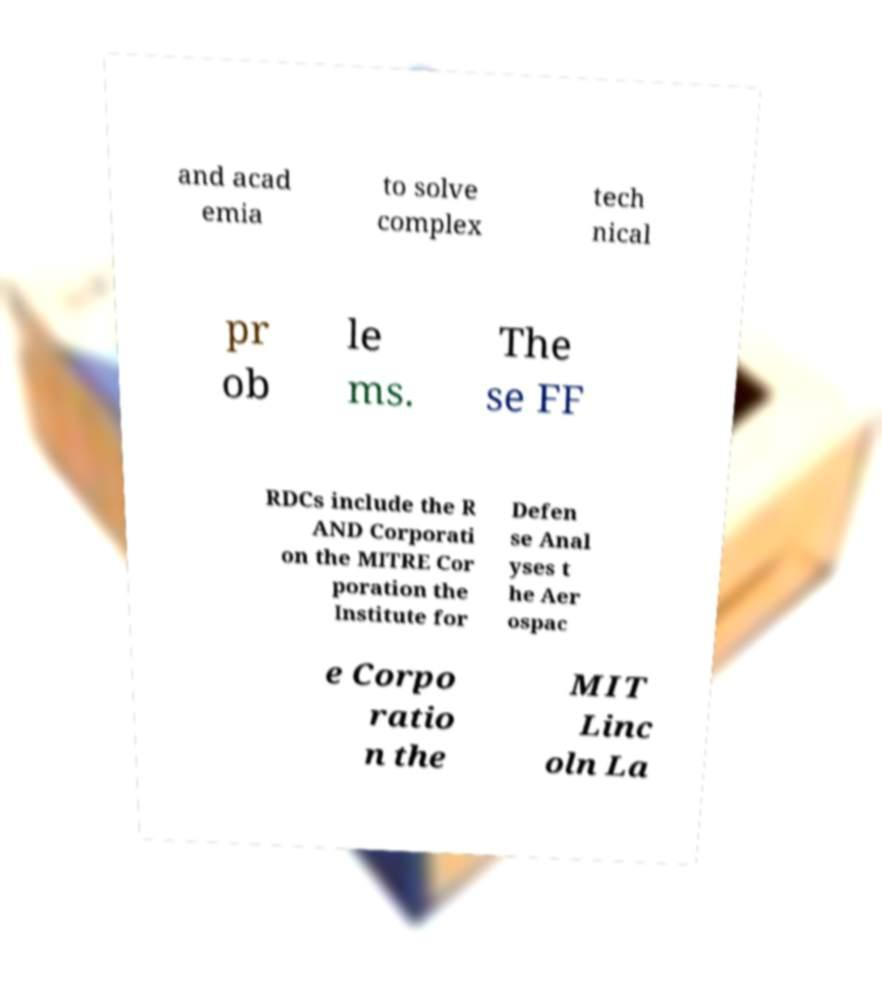Can you accurately transcribe the text from the provided image for me? and acad emia to solve complex tech nical pr ob le ms. The se FF RDCs include the R AND Corporati on the MITRE Cor poration the Institute for Defen se Anal yses t he Aer ospac e Corpo ratio n the MIT Linc oln La 